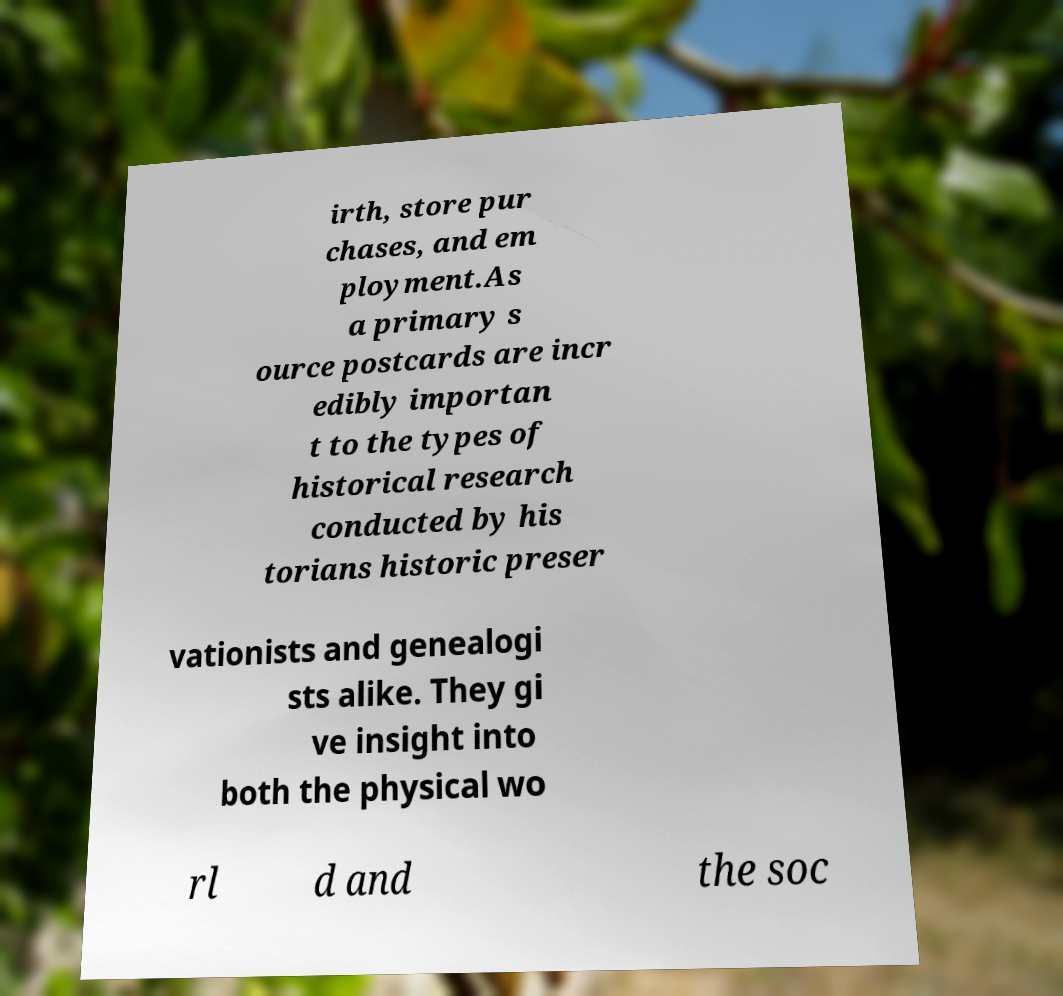Could you assist in decoding the text presented in this image and type it out clearly? irth, store pur chases, and em ployment.As a primary s ource postcards are incr edibly importan t to the types of historical research conducted by his torians historic preser vationists and genealogi sts alike. They gi ve insight into both the physical wo rl d and the soc 